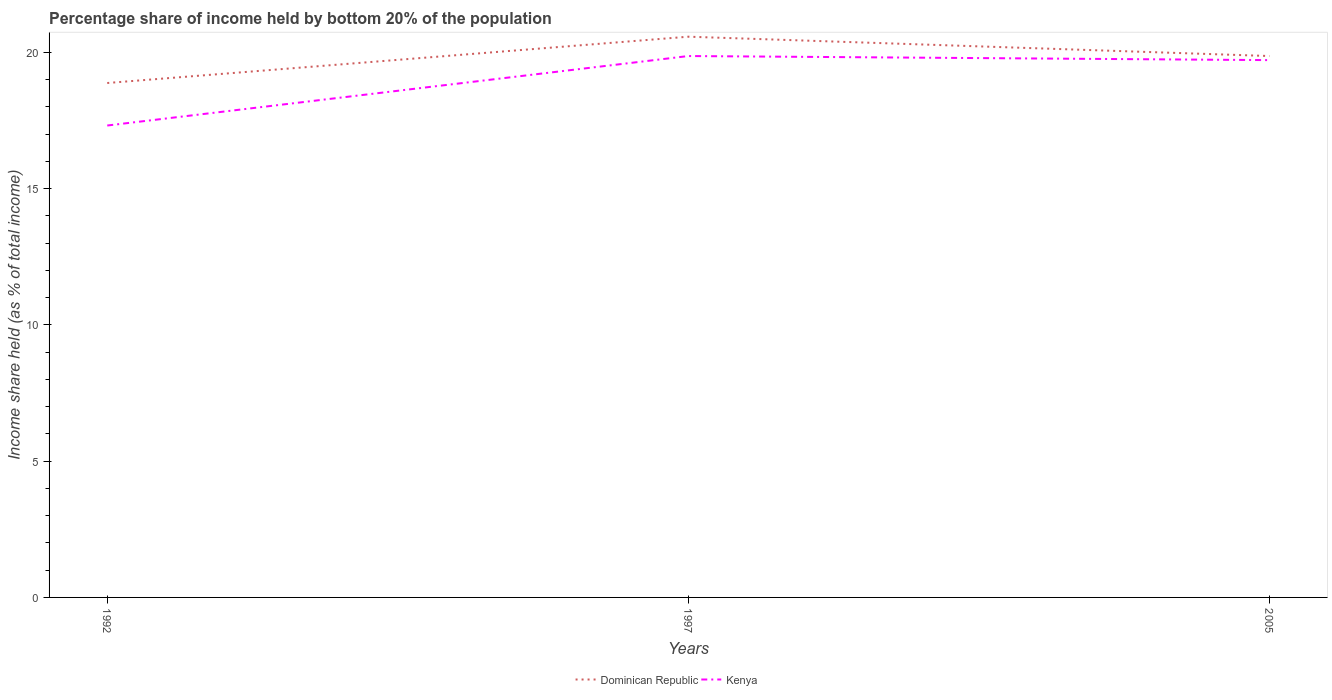Is the number of lines equal to the number of legend labels?
Keep it short and to the point. Yes. Across all years, what is the maximum share of income held by bottom 20% of the population in Kenya?
Make the answer very short. 17.32. What is the total share of income held by bottom 20% of the population in Dominican Republic in the graph?
Keep it short and to the point. -1.7. What is the difference between the highest and the second highest share of income held by bottom 20% of the population in Dominican Republic?
Your response must be concise. 1.7. Is the share of income held by bottom 20% of the population in Dominican Republic strictly greater than the share of income held by bottom 20% of the population in Kenya over the years?
Provide a short and direct response. No. How many lines are there?
Provide a succinct answer. 2. How many years are there in the graph?
Give a very brief answer. 3. Are the values on the major ticks of Y-axis written in scientific E-notation?
Your answer should be very brief. No. Where does the legend appear in the graph?
Your response must be concise. Bottom center. How many legend labels are there?
Keep it short and to the point. 2. How are the legend labels stacked?
Keep it short and to the point. Horizontal. What is the title of the graph?
Keep it short and to the point. Percentage share of income held by bottom 20% of the population. Does "Chile" appear as one of the legend labels in the graph?
Ensure brevity in your answer.  No. What is the label or title of the Y-axis?
Offer a terse response. Income share held (as % of total income). What is the Income share held (as % of total income) in Dominican Republic in 1992?
Offer a very short reply. 18.88. What is the Income share held (as % of total income) of Kenya in 1992?
Your answer should be very brief. 17.32. What is the Income share held (as % of total income) of Dominican Republic in 1997?
Offer a terse response. 20.58. What is the Income share held (as % of total income) in Kenya in 1997?
Provide a short and direct response. 19.87. What is the Income share held (as % of total income) of Dominican Republic in 2005?
Provide a short and direct response. 19.87. What is the Income share held (as % of total income) of Kenya in 2005?
Provide a succinct answer. 19.72. Across all years, what is the maximum Income share held (as % of total income) in Dominican Republic?
Provide a succinct answer. 20.58. Across all years, what is the maximum Income share held (as % of total income) in Kenya?
Offer a very short reply. 19.87. Across all years, what is the minimum Income share held (as % of total income) in Dominican Republic?
Offer a very short reply. 18.88. Across all years, what is the minimum Income share held (as % of total income) in Kenya?
Provide a succinct answer. 17.32. What is the total Income share held (as % of total income) in Dominican Republic in the graph?
Keep it short and to the point. 59.33. What is the total Income share held (as % of total income) in Kenya in the graph?
Give a very brief answer. 56.91. What is the difference between the Income share held (as % of total income) in Kenya in 1992 and that in 1997?
Keep it short and to the point. -2.55. What is the difference between the Income share held (as % of total income) in Dominican Republic in 1992 and that in 2005?
Make the answer very short. -0.99. What is the difference between the Income share held (as % of total income) in Dominican Republic in 1997 and that in 2005?
Give a very brief answer. 0.71. What is the difference between the Income share held (as % of total income) of Kenya in 1997 and that in 2005?
Offer a terse response. 0.15. What is the difference between the Income share held (as % of total income) in Dominican Republic in 1992 and the Income share held (as % of total income) in Kenya in 1997?
Your answer should be compact. -0.99. What is the difference between the Income share held (as % of total income) in Dominican Republic in 1992 and the Income share held (as % of total income) in Kenya in 2005?
Your answer should be very brief. -0.84. What is the difference between the Income share held (as % of total income) of Dominican Republic in 1997 and the Income share held (as % of total income) of Kenya in 2005?
Keep it short and to the point. 0.86. What is the average Income share held (as % of total income) of Dominican Republic per year?
Offer a very short reply. 19.78. What is the average Income share held (as % of total income) of Kenya per year?
Keep it short and to the point. 18.97. In the year 1992, what is the difference between the Income share held (as % of total income) of Dominican Republic and Income share held (as % of total income) of Kenya?
Your answer should be compact. 1.56. In the year 1997, what is the difference between the Income share held (as % of total income) in Dominican Republic and Income share held (as % of total income) in Kenya?
Keep it short and to the point. 0.71. What is the ratio of the Income share held (as % of total income) in Dominican Republic in 1992 to that in 1997?
Ensure brevity in your answer.  0.92. What is the ratio of the Income share held (as % of total income) of Kenya in 1992 to that in 1997?
Provide a succinct answer. 0.87. What is the ratio of the Income share held (as % of total income) of Dominican Republic in 1992 to that in 2005?
Keep it short and to the point. 0.95. What is the ratio of the Income share held (as % of total income) in Kenya in 1992 to that in 2005?
Keep it short and to the point. 0.88. What is the ratio of the Income share held (as % of total income) in Dominican Republic in 1997 to that in 2005?
Make the answer very short. 1.04. What is the ratio of the Income share held (as % of total income) of Kenya in 1997 to that in 2005?
Your answer should be very brief. 1.01. What is the difference between the highest and the second highest Income share held (as % of total income) of Dominican Republic?
Keep it short and to the point. 0.71. What is the difference between the highest and the lowest Income share held (as % of total income) in Kenya?
Your answer should be very brief. 2.55. 